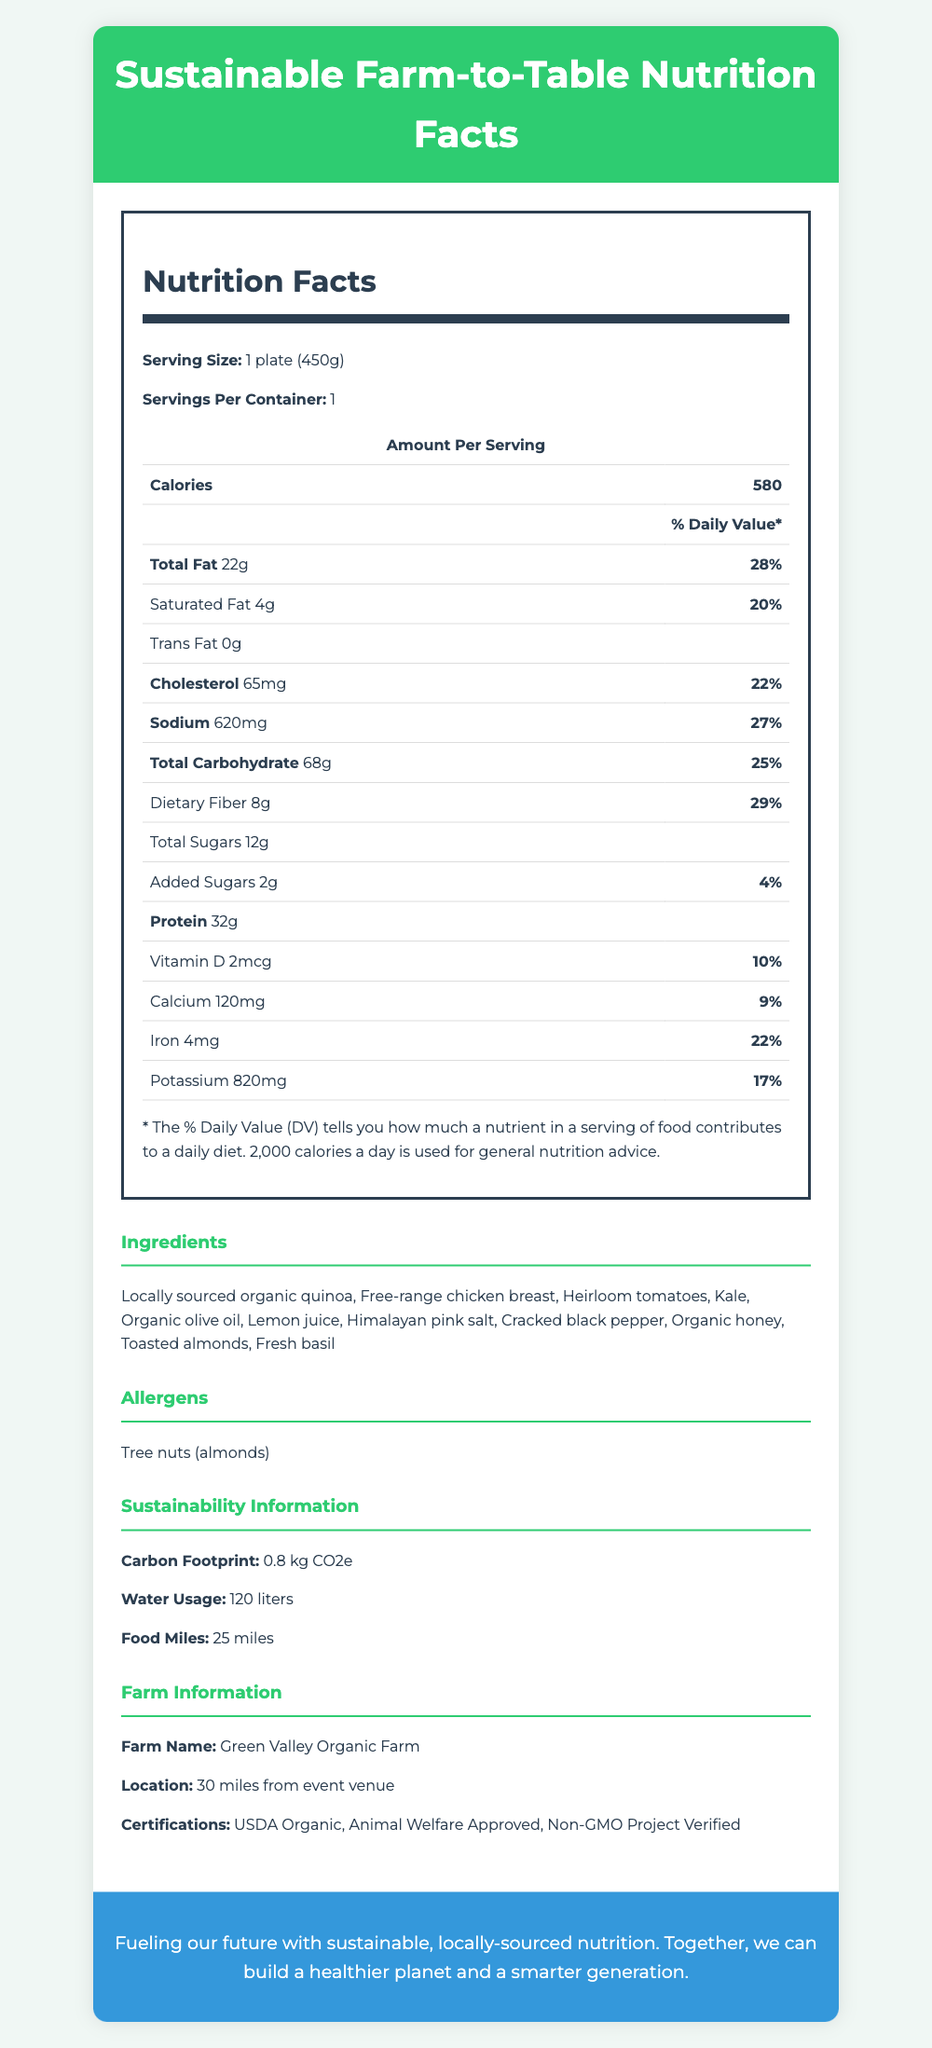what is the serving size of the meal? The document lists the serving size as "1 plate (450g)."
Answer: 1 plate (450g) how many calories are there per serving? The document specifies that there are 580 calories per serving.
Answer: 580 what is the amount of protein in the meal? The protein content per serving is listed as 32g in the document.
Answer: 32g which nutrient has the highest daily value percentage? Among the nutrients, Total Fat has the highest daily value percentage at 28%.
Answer: Total Fat (28%) how much cholesterol does the meal contain? The document indicates that the meal contains 65mg of cholesterol.
Answer: 65mg what is the daily value percentage of iron in the meal? A. 9% B. 22% C. 29% D. 17% The document states that the iron content has a daily value of 22%.
Answer: B. 22% which certification is NOT held by Green Valley Organic Farm? I. USDA Organic II. Fair Trade Certified III. Non-GMO Project Verified IV. Animal Welfare Approved The document lists the certifications as USDA Organic, Animal Welfare Approved, and Non-GMO Project Verified. Fair Trade Certified is not mentioned.
Answer: II. Fair Trade Certified does the meal contain any trans fat? According to the document, the trans fat content is listed as 0g.
Answer: No what are the three sustainability metrics provided? The document includes sustainability information for carbon footprint, water usage, and food miles.
Answer: Carbon Footprint, Water Usage, Food Miles summarize the main idea of the document. The main idea focuses on detailing the nutritional content, ingredient sources, and sustainability aspects of the catered meal, underscoring the campaign's commitment to healthy and environmentally friendly choices.
Answer: The document provides detailed nutrition facts, ingredients, allergens, sustainability information, and farm details for a sustainable, farm-to-table catered meal at a campaign event. It emphasizes the use of locally-sourced and organic ingredients to promote health and sustainability. how far is Green Valley Organic Farm from the event venue? The document states that Green Valley Organic Farm is 30 miles from the event venue.
Answer: 30 miles which of the following ingredients is an allergen listed in the document? 1. Kale 2. Heirloom tomatoes 3. Free-range chicken breast 4. Tree nuts (almonds) The document mentions that tree nuts (almonds) are an allergen in the meal.
Answer: 4. Tree nuts (almonds) what is the carbon footprint of the meal in kg CO2e? The document specifies that the carbon footprint of the meal is 0.8 kg CO2e.
Answer: 0.8 kg CO2e can it be determined how often similar meals are served at the campaign events? The document does not provide any information about the frequency of serving similar meals at campaign events.
Answer: Cannot be determined 